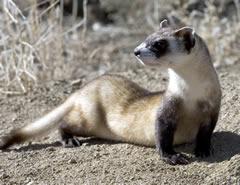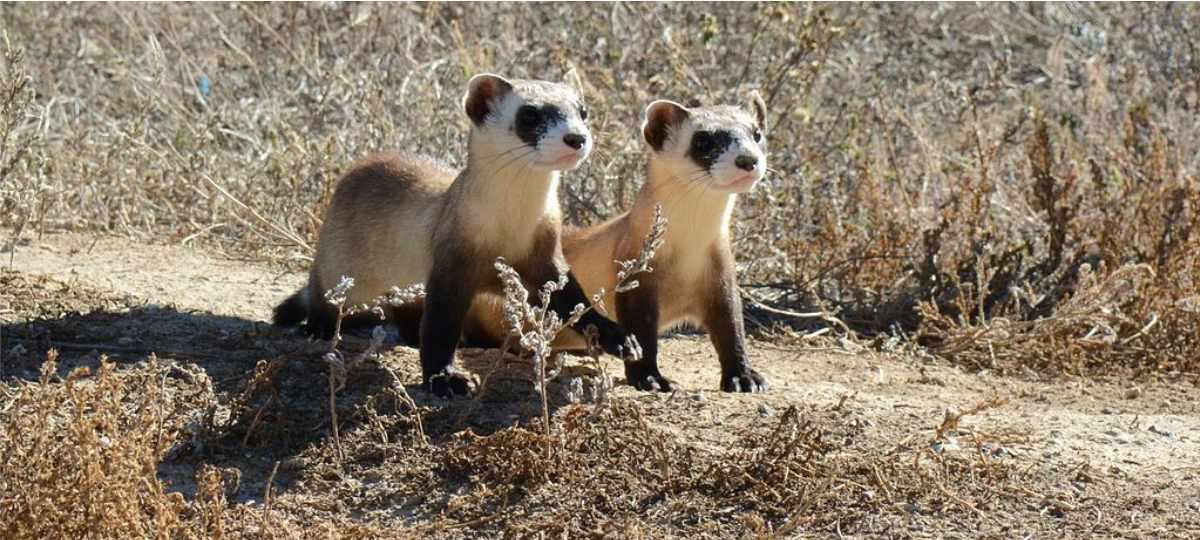The first image is the image on the left, the second image is the image on the right. For the images displayed, is the sentence "There are exactly two ferrets." factually correct? Answer yes or no. No. 